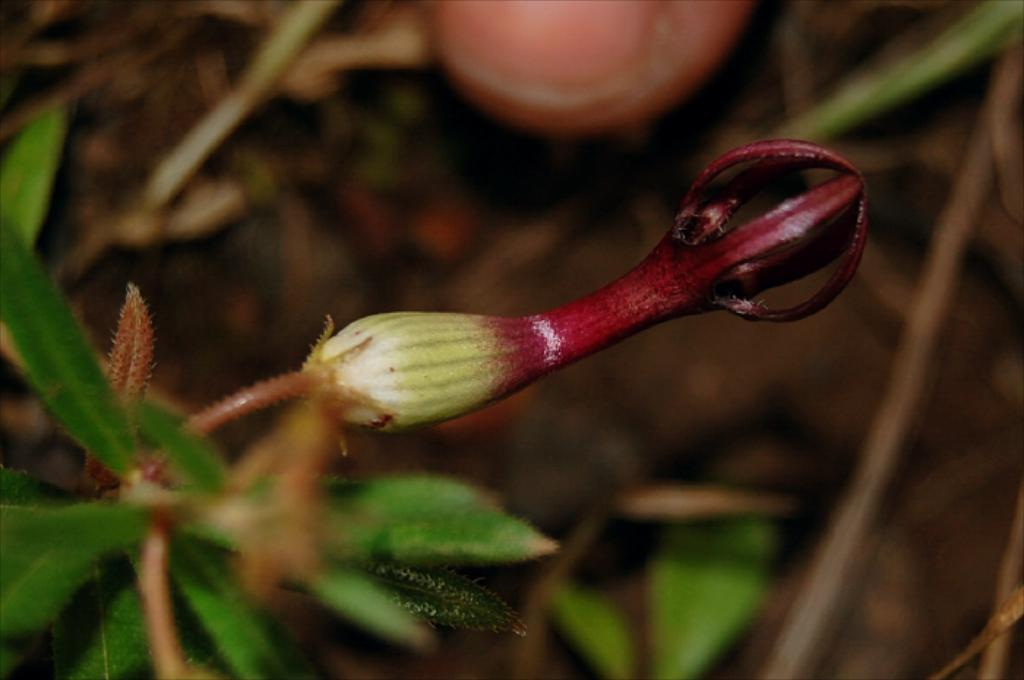What type of plant is visible in the image? There is a plant in the image, but the specific type cannot be determined from the provided facts. What features of the plant can be seen? The plant has leaves and a bud. Is there any indication of the plant's reproductive stage? Yes, the presence of a bud suggests that the plant is in the process of producing flowers or fruit. What is located at the top of the image? There appears to be a fruit at the top of the image. How would you describe the background of the image? The background of the image is blurred. What type of vessel is used to provide comfort to the plant in the image? There is no vessel or indication of comfort provided to the plant in the image. 